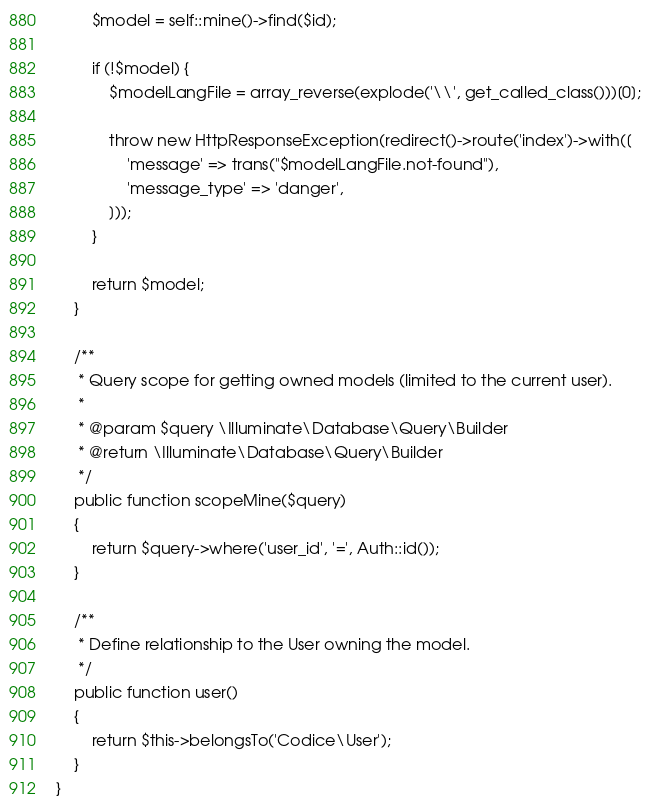Convert code to text. <code><loc_0><loc_0><loc_500><loc_500><_PHP_>        $model = self::mine()->find($id);

        if (!$model) {
            $modelLangFile = array_reverse(explode('\\', get_called_class()))[0];

            throw new HttpResponseException(redirect()->route('index')->with([
                'message' => trans("$modelLangFile.not-found"),
                'message_type' => 'danger',
            ]));
        }

        return $model;
    }

    /**
     * Query scope for getting owned models (limited to the current user).
     *
     * @param $query \Illuminate\Database\Query\Builder
     * @return \Illuminate\Database\Query\Builder
     */
    public function scopeMine($query)
    {
        return $query->where('user_id', '=', Auth::id());
    }

    /**
     * Define relationship to the User owning the model.
     */
    public function user()
    {
        return $this->belongsTo('Codice\User');
    }
}
</code> 